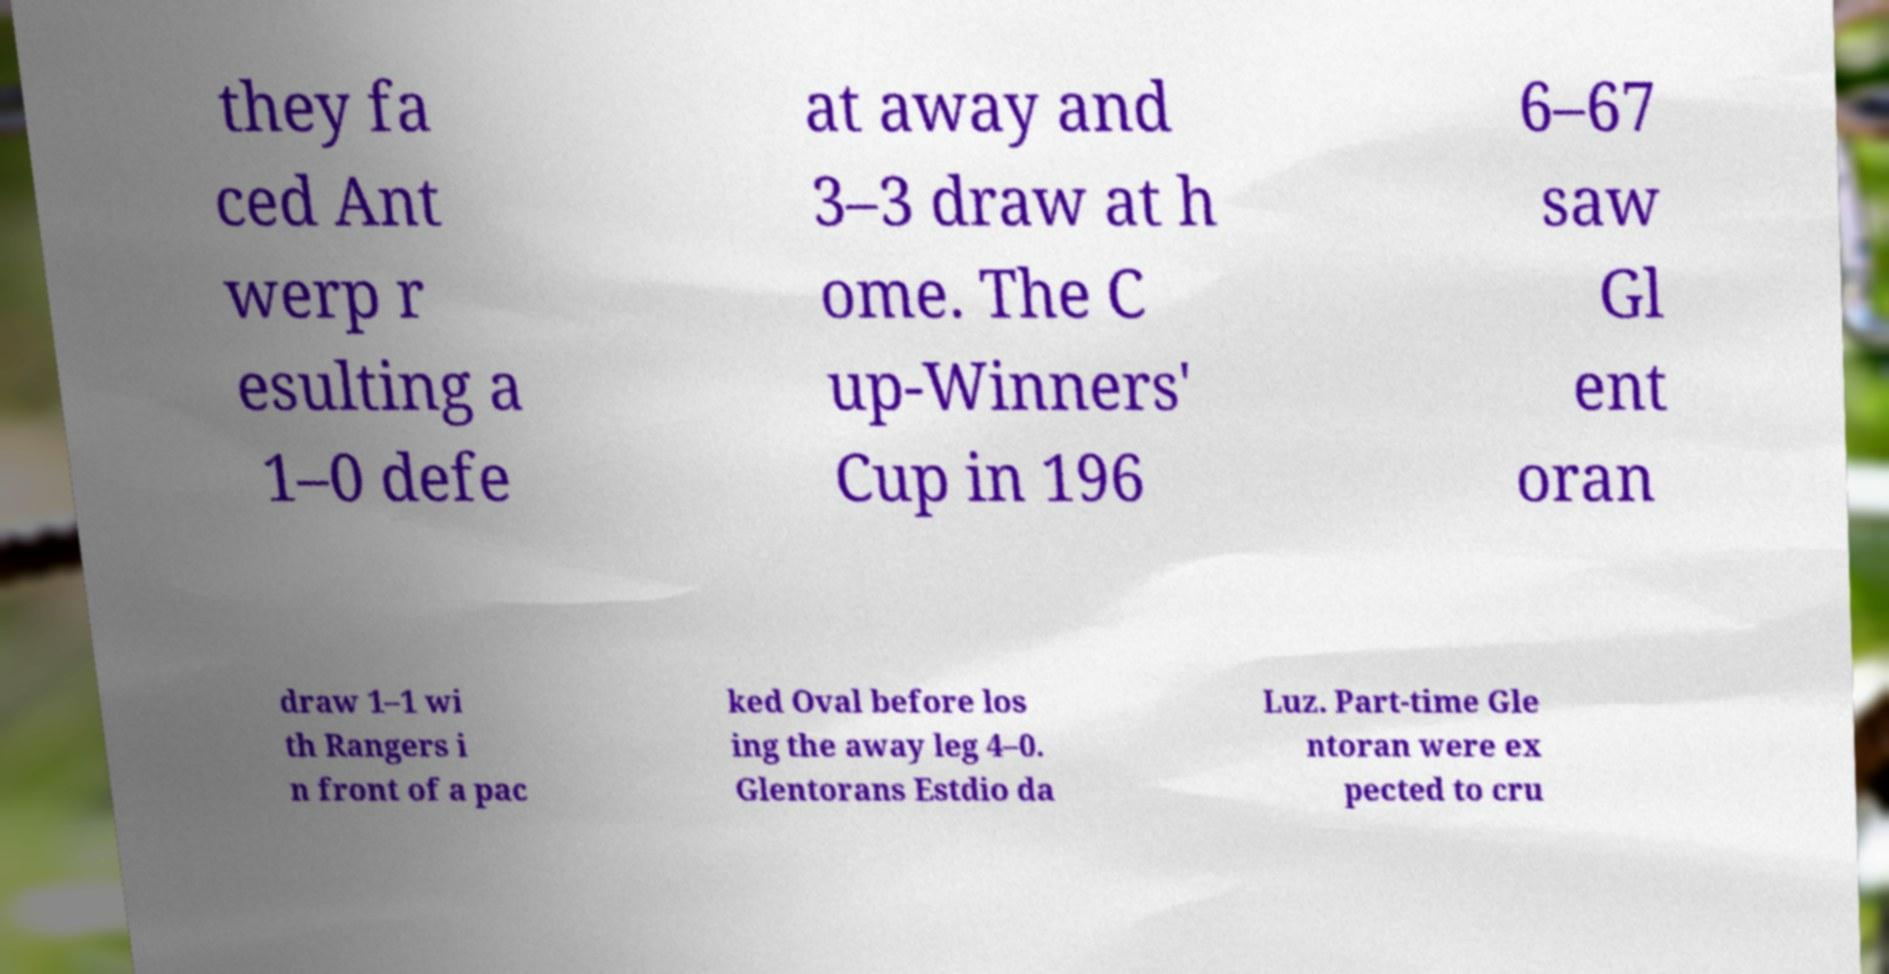Could you assist in decoding the text presented in this image and type it out clearly? they fa ced Ant werp r esulting a 1–0 defe at away and 3–3 draw at h ome. The C up-Winners' Cup in 196 6–67 saw Gl ent oran draw 1–1 wi th Rangers i n front of a pac ked Oval before los ing the away leg 4–0. Glentorans Estdio da Luz. Part-time Gle ntoran were ex pected to cru 